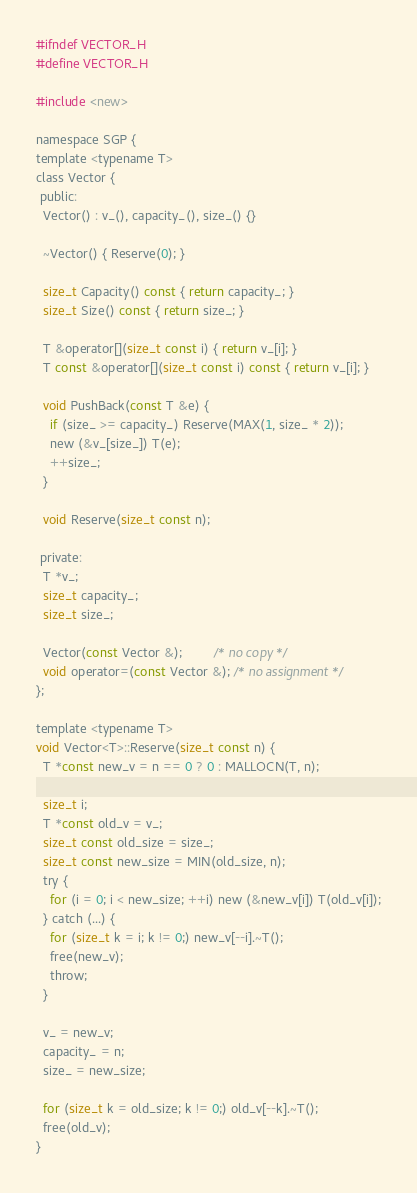<code> <loc_0><loc_0><loc_500><loc_500><_C_>#ifndef VECTOR_H
#define VECTOR_H

#include <new>

namespace SGP {
template <typename T>
class Vector {
 public:
  Vector() : v_(), capacity_(), size_() {}

  ~Vector() { Reserve(0); }

  size_t Capacity() const { return capacity_; }
  size_t Size() const { return size_; }

  T &operator[](size_t const i) { return v_[i]; }
  T const &operator[](size_t const i) const { return v_[i]; }

  void PushBack(const T &e) {
    if (size_ >= capacity_) Reserve(MAX(1, size_ * 2));
    new (&v_[size_]) T(e);
    ++size_;
  }

  void Reserve(size_t const n);

 private:
  T *v_;
  size_t capacity_;
  size_t size_;

  Vector(const Vector &);         /* no copy */
  void operator=(const Vector &); /* no assignment */
};

template <typename T>
void Vector<T>::Reserve(size_t const n) {
  T *const new_v = n == 0 ? 0 : MALLOCN(T, n);

  size_t i;
  T *const old_v = v_;
  size_t const old_size = size_;
  size_t const new_size = MIN(old_size, n);
  try {
    for (i = 0; i < new_size; ++i) new (&new_v[i]) T(old_v[i]);
  } catch (...) {
    for (size_t k = i; k != 0;) new_v[--i].~T();
    free(new_v);
    throw;
  }

  v_ = new_v;
  capacity_ = n;
  size_ = new_size;

  for (size_t k = old_size; k != 0;) old_v[--k].~T();
  free(old_v);
}</code> 